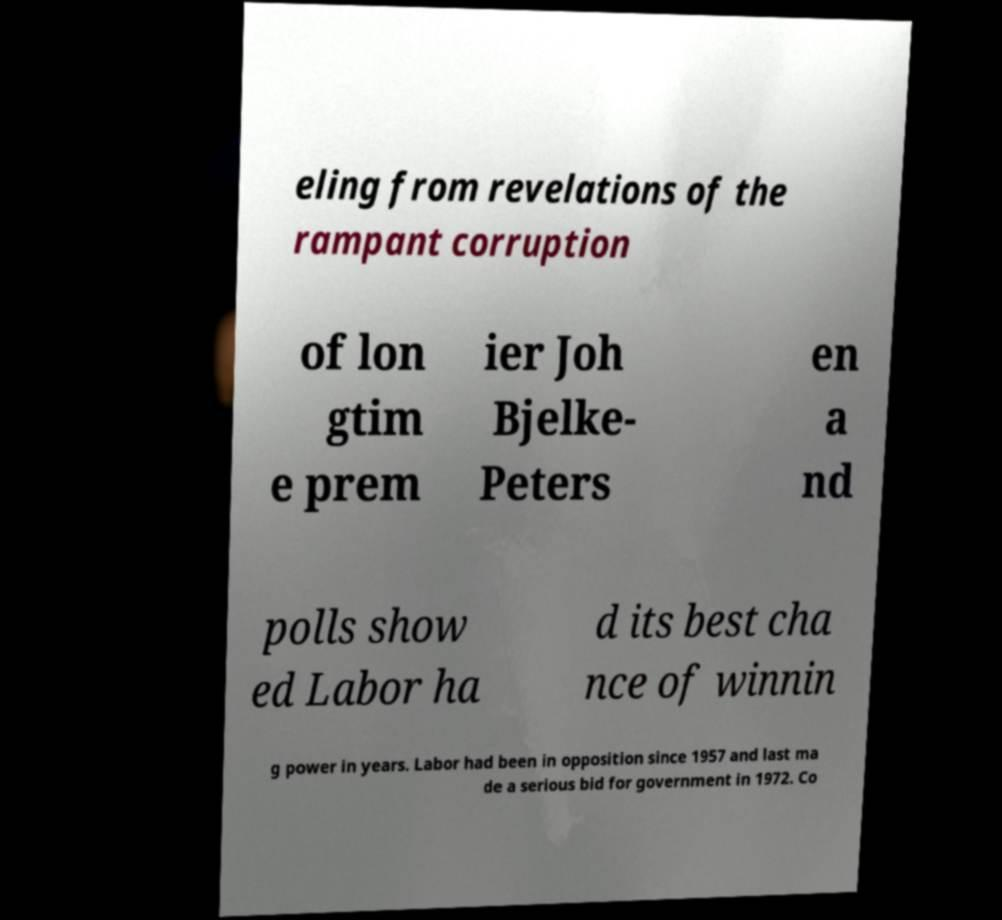Can you read and provide the text displayed in the image?This photo seems to have some interesting text. Can you extract and type it out for me? eling from revelations of the rampant corruption of lon gtim e prem ier Joh Bjelke- Peters en a nd polls show ed Labor ha d its best cha nce of winnin g power in years. Labor had been in opposition since 1957 and last ma de a serious bid for government in 1972. Co 